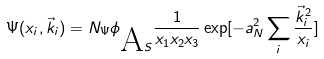<formula> <loc_0><loc_0><loc_500><loc_500>\Psi ( x _ { i } , \vec { k } _ { i } ) = N _ { \Psi } \phi _ { \mbox A S } \frac { 1 } { x _ { 1 } x _ { 2 } x _ { 3 } } \exp [ - a _ { N } ^ { 2 } \sum _ { i } \frac { \vec { k } _ { i } ^ { 2 } } { x _ { i } } ]</formula> 